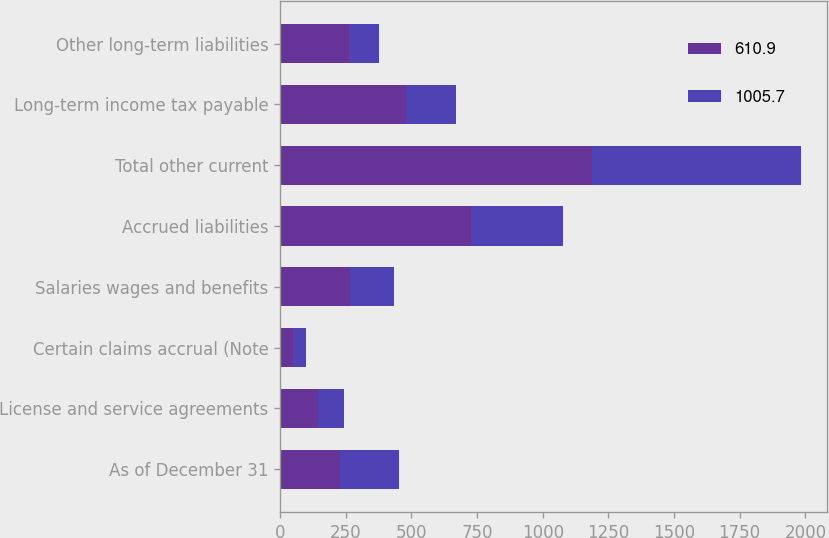Convert chart to OTSL. <chart><loc_0><loc_0><loc_500><loc_500><stacked_bar_chart><ecel><fcel>As of December 31<fcel>License and service agreements<fcel>Certain claims accrual (Note<fcel>Salaries wages and benefits<fcel>Accrued liabilities<fcel>Total other current<fcel>Long-term income tax payable<fcel>Other long-term liabilities<nl><fcel>610.9<fcel>226.45<fcel>144.1<fcel>50<fcel>265.9<fcel>725.9<fcel>1185.9<fcel>478.1<fcel>263<nl><fcel>1005.7<fcel>226.45<fcel>100.2<fcel>50<fcel>167.7<fcel>351.3<fcel>798.5<fcel>189.9<fcel>113.8<nl></chart> 